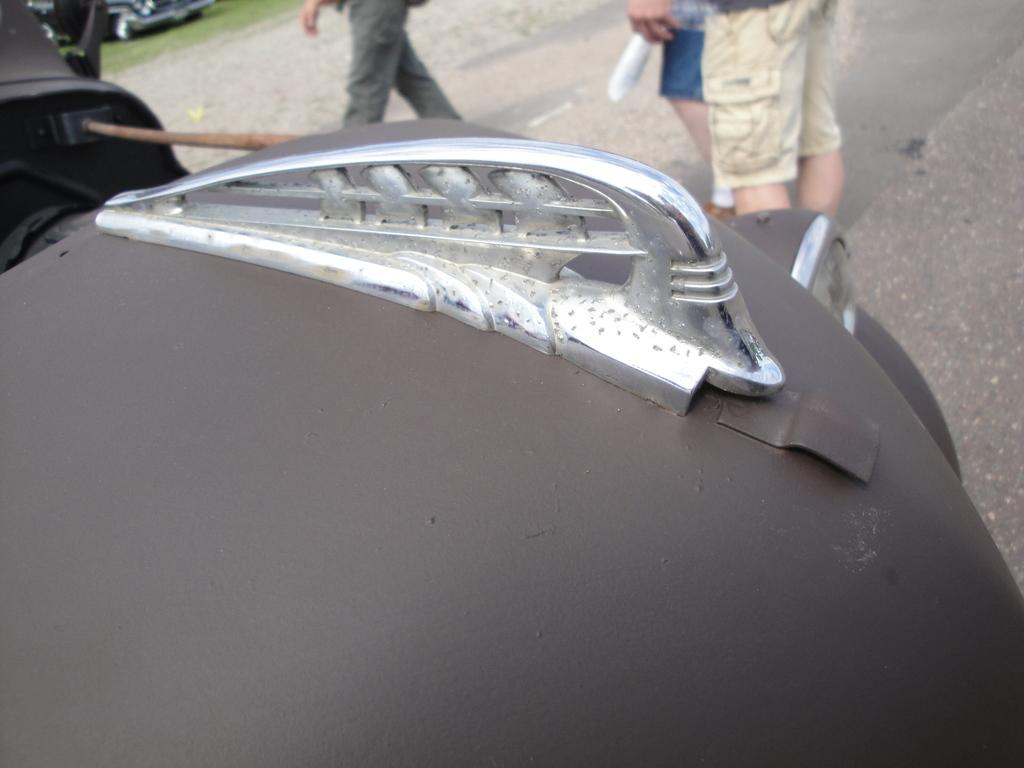What is the main subject in the middle of the image? There is a car fender in the middle of the image. Can you describe the people visible in the image? There are people visible in the image, but their specific actions or features are not mentioned in the facts. What type of vehicle is present in the image? There is a vehicle in the image, but its specific make or model is not mentioned in the facts. What type of terrain is visible in the image? Grass is present in the image, and there is also a road visible. Is there a volcano erupting in the background of the image? There is no mention of a volcano in the provided facts, so it cannot be determined if one is present in the image. 